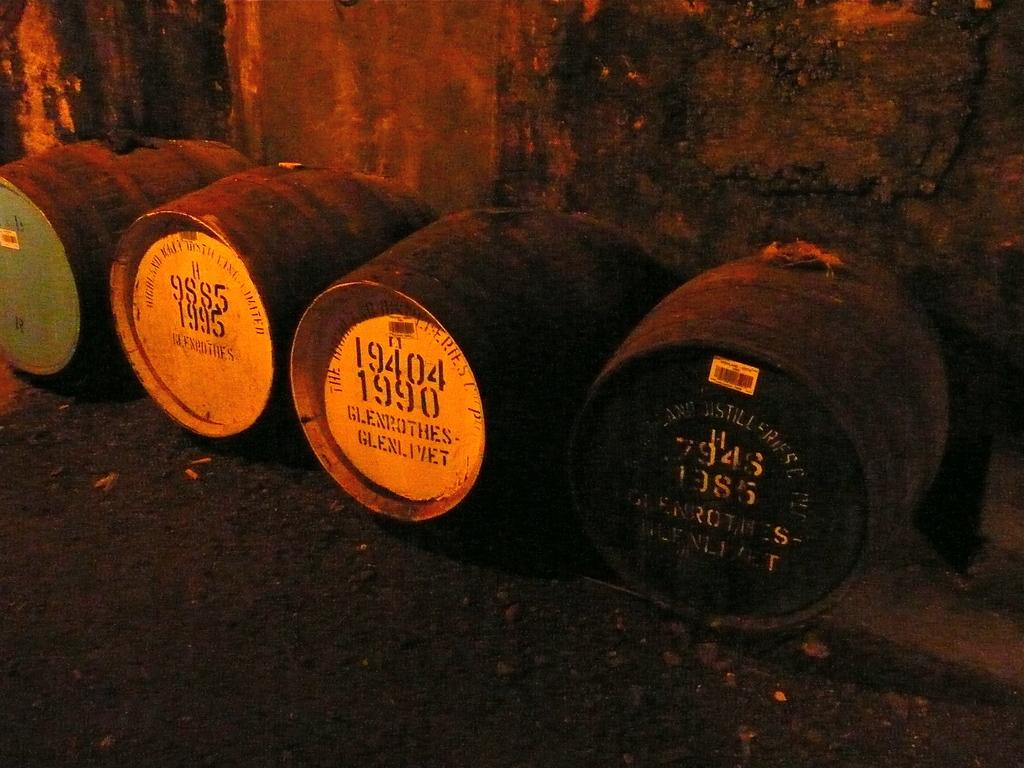What objects are on the ground in the image? There are barrels on the ground in the image. What can be seen on the barrels? The barrels have stickers and text on them. What is visible in the background of the image? There is a wall visible in the background of the image. What type of gun is being fired in the image? There is no gun or any indication of firing in the image; it only features barrels with stickers and text on them and a wall in the background. 